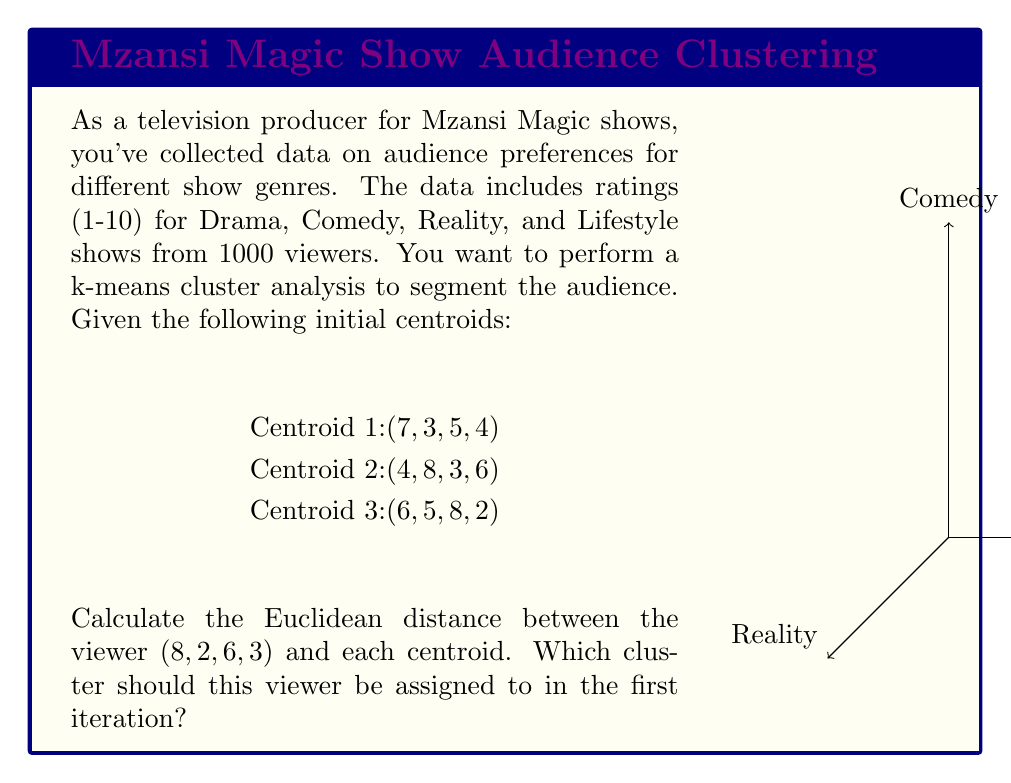Can you answer this question? To determine which cluster the viewer should be assigned to, we need to calculate the Euclidean distance between the viewer's ratings and each centroid, then assign the viewer to the cluster with the smallest distance.

The Euclidean distance in 4-dimensional space is given by:

$$d = \sqrt{(x_1-c_1)^2 + (x_2-c_2)^2 + (x_3-c_3)^2 + (x_4-c_4)^2}$$

Where $(x_1,x_2,x_3,x_4)$ are the viewer's ratings and $(c_1,c_2,c_3,c_4)$ are the centroid coordinates.

1. Distance to Centroid 1:
   $$d_1 = \sqrt{(8-7)^2 + (2-3)^2 + (6-5)^2 + (3-4)^2}$$
   $$d_1 = \sqrt{1^2 + (-1)^2 + 1^2 + (-1)^2} = \sqrt{4} = 2$$

2. Distance to Centroid 2:
   $$d_2 = \sqrt{(8-4)^2 + (2-8)^2 + (6-3)^2 + (3-6)^2}$$
   $$d_2 = \sqrt{4^2 + (-6)^2 + 3^2 + (-3)^2} = \sqrt{70} \approx 8.37$$

3. Distance to Centroid 3:
   $$d_3 = \sqrt{(8-6)^2 + (2-5)^2 + (6-8)^2 + (3-2)^2}$$
   $$d_3 = \sqrt{2^2 + (-3)^2 + (-2)^2 + 1^2} = \sqrt{18} \approx 4.24$$

The smallest distance is $d_1 = 2$, corresponding to Centroid 1.
Answer: Cluster 1 